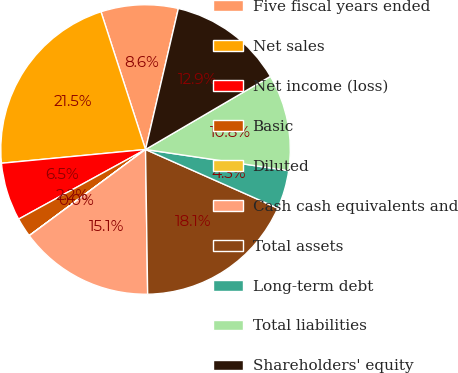<chart> <loc_0><loc_0><loc_500><loc_500><pie_chart><fcel>Five fiscal years ended<fcel>Net sales<fcel>Net income (loss)<fcel>Basic<fcel>Diluted<fcel>Cash cash equivalents and<fcel>Total assets<fcel>Long-term debt<fcel>Total liabilities<fcel>Shareholders' equity<nl><fcel>8.62%<fcel>21.54%<fcel>6.47%<fcel>2.16%<fcel>0.01%<fcel>15.08%<fcel>18.12%<fcel>4.31%<fcel>10.77%<fcel>12.93%<nl></chart> 